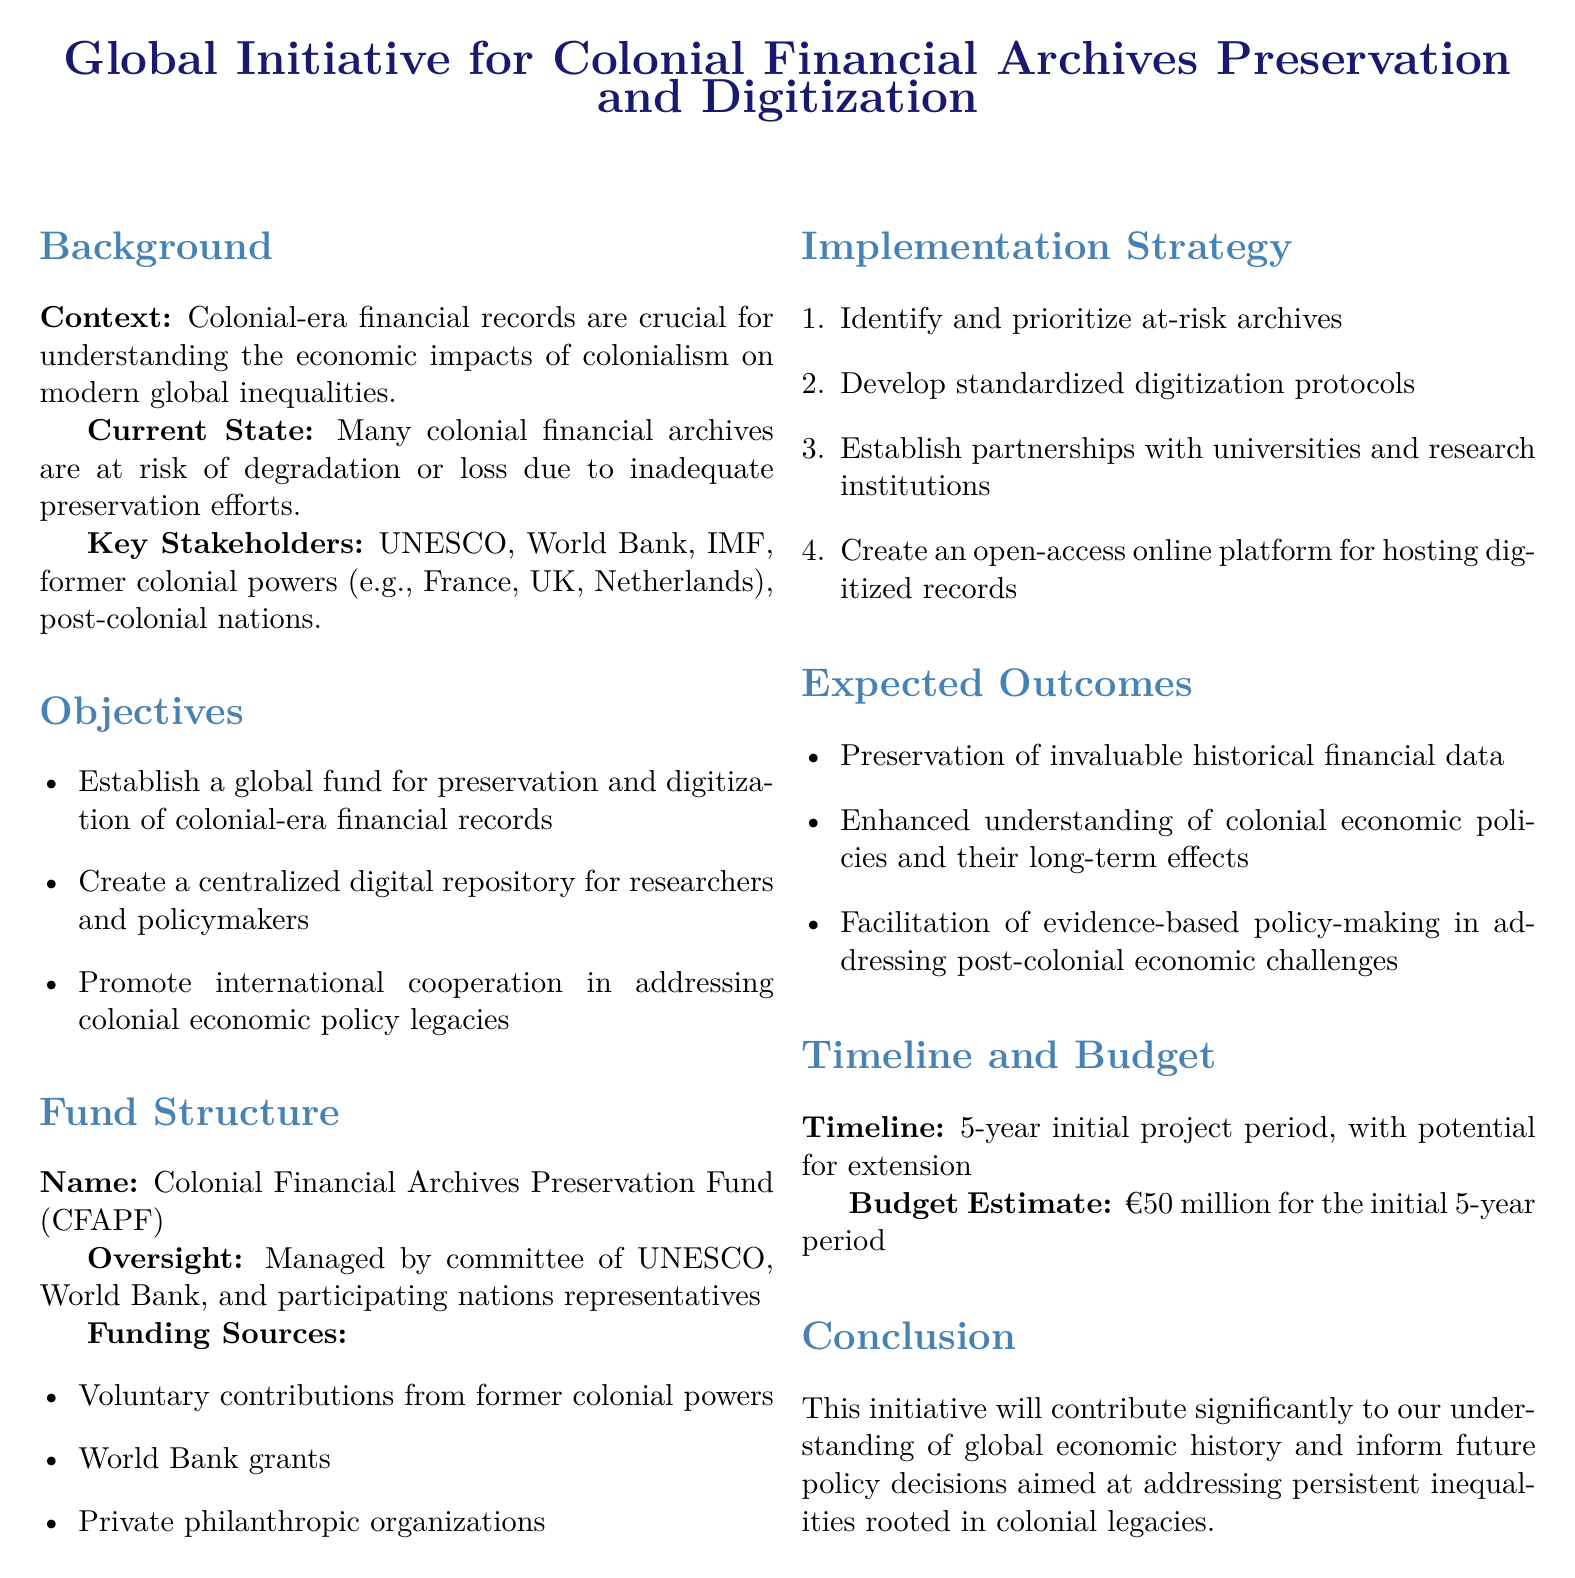What is the name of the fund? The document explicitly states the name of the fund as "Colonial Financial Archives Preservation Fund (CFAPF)."
Answer: Colonial Financial Archives Preservation Fund (CFAPF) Who are the key stakeholders mentioned? The document lists UNESCO, World Bank, IMF, former colonial powers, and post-colonial nations as key stakeholders.
Answer: UNESCO, World Bank, IMF, former colonial powers, post-colonial nations What is the total budget estimate for the initial project period? The document specifies a budget estimate of €50 million for the initial 5-year period.
Answer: €50 million What is the primary objective of the initiative? The first objective mentioned in the document is to establish a global fund for preservation and digitization of colonial-era financial records.
Answer: Establish a global fund for preservation and digitization of colonial-era financial records How long is the initial project period? The document clearly indicates that the initial project period is 5 years.
Answer: 5 years What is the statutory oversight body for the fund? According to the document, the fund is managed by a committee that includes UNESCO, World Bank, and participating nations' representatives.
Answer: UNESCO, World Bank, and participating nations' representatives How will the fund be primarily financed? The document notes that the primary sources of funding include voluntary contributions from former colonial powers, World Bank grants, and private philanthropic organizations.
Answer: Voluntary contributions from former colonial powers, World Bank grants, private philanthropic organizations What is the expected outcome related to understanding colonial economic policies? The document states that one expected outcome is enhanced understanding of colonial economic policies and their long-term effects.
Answer: Enhanced understanding of colonial economic policies and their long-term effects What is the proposed outcome for policymakers? The document mentions the facilitation of evidence-based policy-making in addressing post-colonial economic challenges as an expected outcome.
Answer: Facilitation of evidence-based policy-making in addressing post-colonial economic challenges 